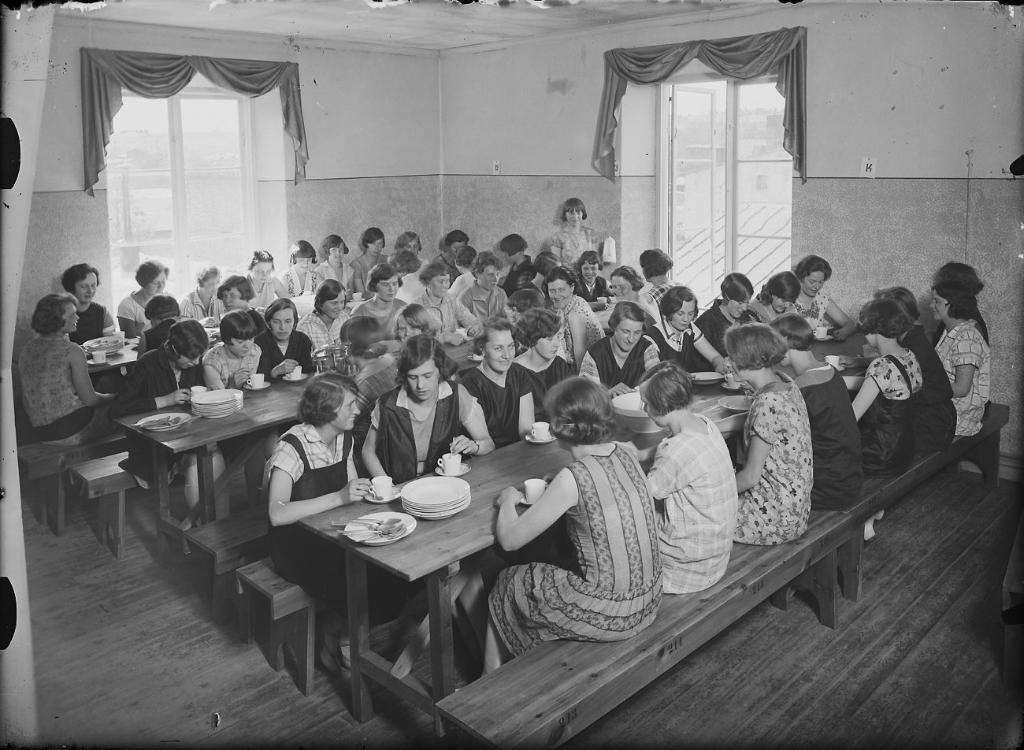What is the color scheme of the image? The image is in black and white. What are the people in the image doing? The people are sitting in front of tables. Can you describe the setting of the image? The setting appears to be a dining hall. What can be seen in the background of the image? There is a wall and two windows in the background. What type of window treatment is present in the image? There are curtains associated with the windows. What type of faucet can be seen in the image? There is no faucet present in the image. What type of current is being used to power the dining hall in the image? The image is in black and white, so it does not provide information about the type of current being used. Additionally, the image does not show any electrical components or appliances that would require power. What type of beef is being served in the image? The image does not show any food items, so it is impossible to determine what type of beef, if any, is being served. 